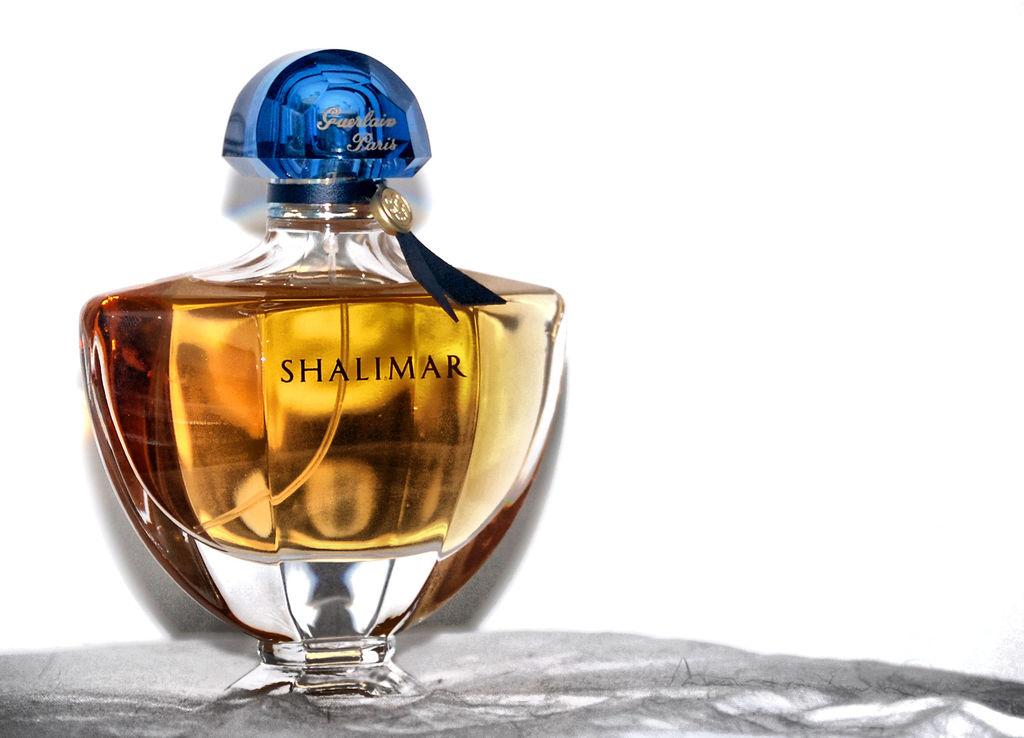<image>
Write a terse but informative summary of the picture. Bottle of Shalimar with a blue cap on a surface. 